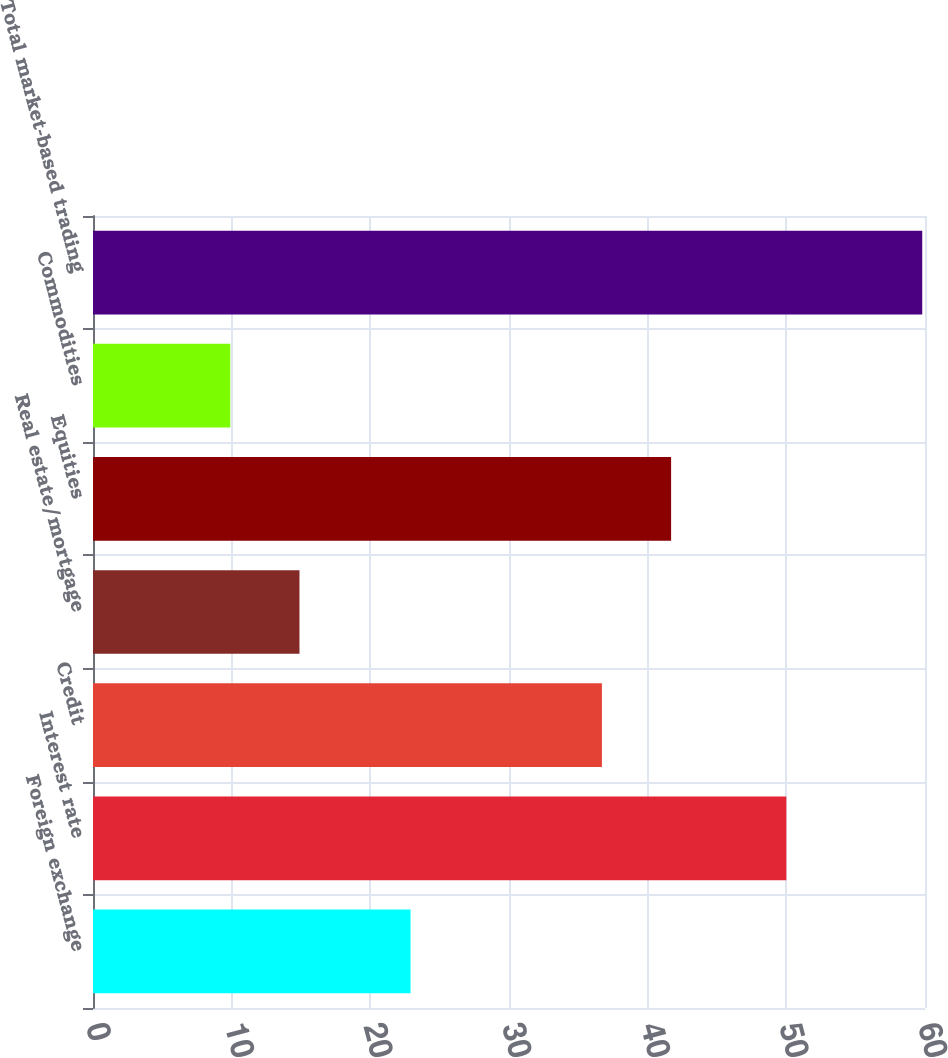Convert chart. <chart><loc_0><loc_0><loc_500><loc_500><bar_chart><fcel>Foreign exchange<fcel>Interest rate<fcel>Credit<fcel>Real estate/mortgage<fcel>Equities<fcel>Commodities<fcel>Total market-based trading<nl><fcel>22.9<fcel>50<fcel>36.7<fcel>14.89<fcel>41.69<fcel>9.9<fcel>59.8<nl></chart> 